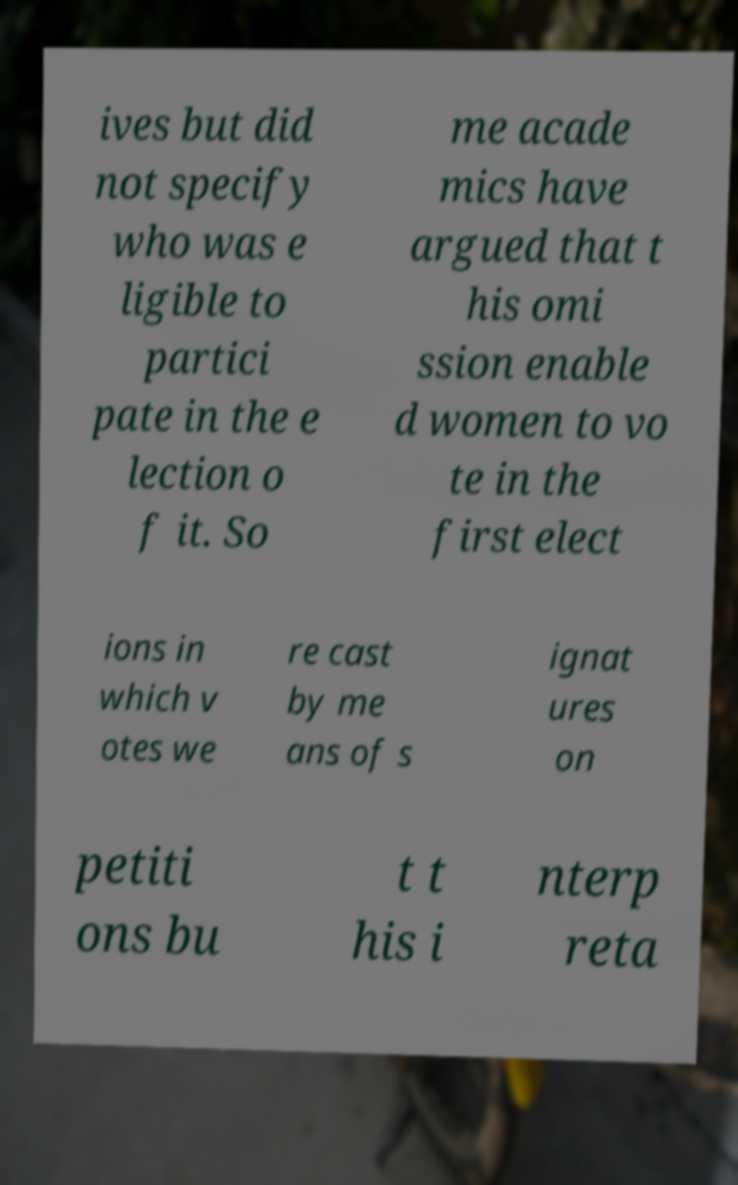Could you assist in decoding the text presented in this image and type it out clearly? ives but did not specify who was e ligible to partici pate in the e lection o f it. So me acade mics have argued that t his omi ssion enable d women to vo te in the first elect ions in which v otes we re cast by me ans of s ignat ures on petiti ons bu t t his i nterp reta 